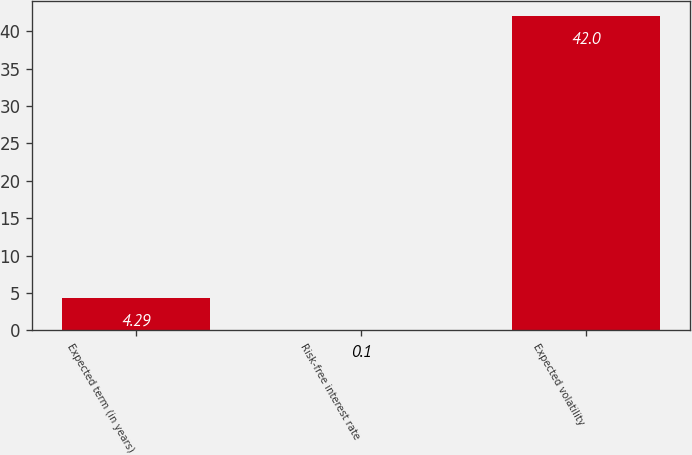Convert chart. <chart><loc_0><loc_0><loc_500><loc_500><bar_chart><fcel>Expected term (in years)<fcel>Risk-free interest rate<fcel>Expected volatility<nl><fcel>4.29<fcel>0.1<fcel>42<nl></chart> 